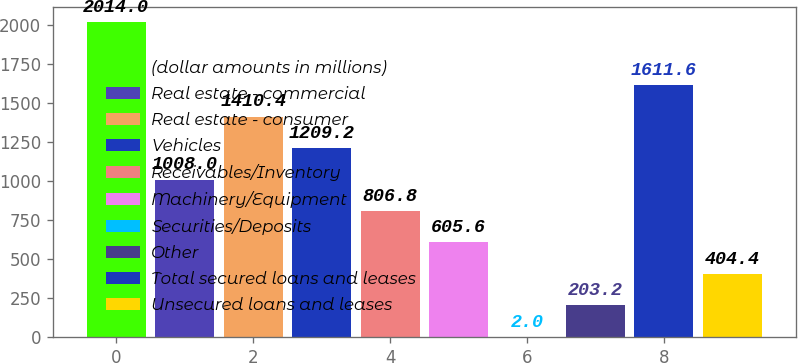Convert chart to OTSL. <chart><loc_0><loc_0><loc_500><loc_500><bar_chart><fcel>(dollar amounts in millions)<fcel>Real estate - commercial<fcel>Real estate - consumer<fcel>Vehicles<fcel>Receivables/Inventory<fcel>Machinery/Equipment<fcel>Securities/Deposits<fcel>Other<fcel>Total secured loans and leases<fcel>Unsecured loans and leases<nl><fcel>2014<fcel>1008<fcel>1410.4<fcel>1209.2<fcel>806.8<fcel>605.6<fcel>2<fcel>203.2<fcel>1611.6<fcel>404.4<nl></chart> 